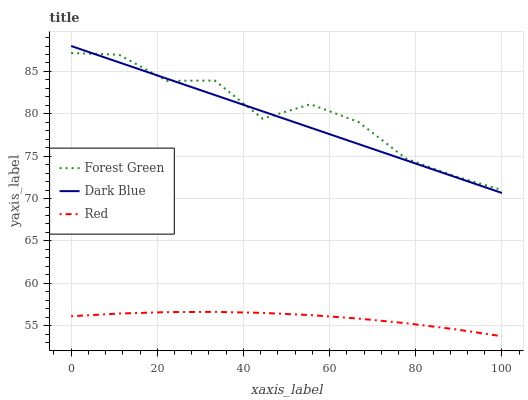Does Red have the minimum area under the curve?
Answer yes or no. Yes. Does Forest Green have the maximum area under the curve?
Answer yes or no. Yes. Does Forest Green have the minimum area under the curve?
Answer yes or no. No. Does Red have the maximum area under the curve?
Answer yes or no. No. Is Dark Blue the smoothest?
Answer yes or no. Yes. Is Forest Green the roughest?
Answer yes or no. Yes. Is Red the smoothest?
Answer yes or no. No. Is Red the roughest?
Answer yes or no. No. Does Red have the lowest value?
Answer yes or no. Yes. Does Forest Green have the lowest value?
Answer yes or no. No. Does Dark Blue have the highest value?
Answer yes or no. Yes. Does Forest Green have the highest value?
Answer yes or no. No. Is Red less than Dark Blue?
Answer yes or no. Yes. Is Forest Green greater than Red?
Answer yes or no. Yes. Does Forest Green intersect Dark Blue?
Answer yes or no. Yes. Is Forest Green less than Dark Blue?
Answer yes or no. No. Is Forest Green greater than Dark Blue?
Answer yes or no. No. Does Red intersect Dark Blue?
Answer yes or no. No. 